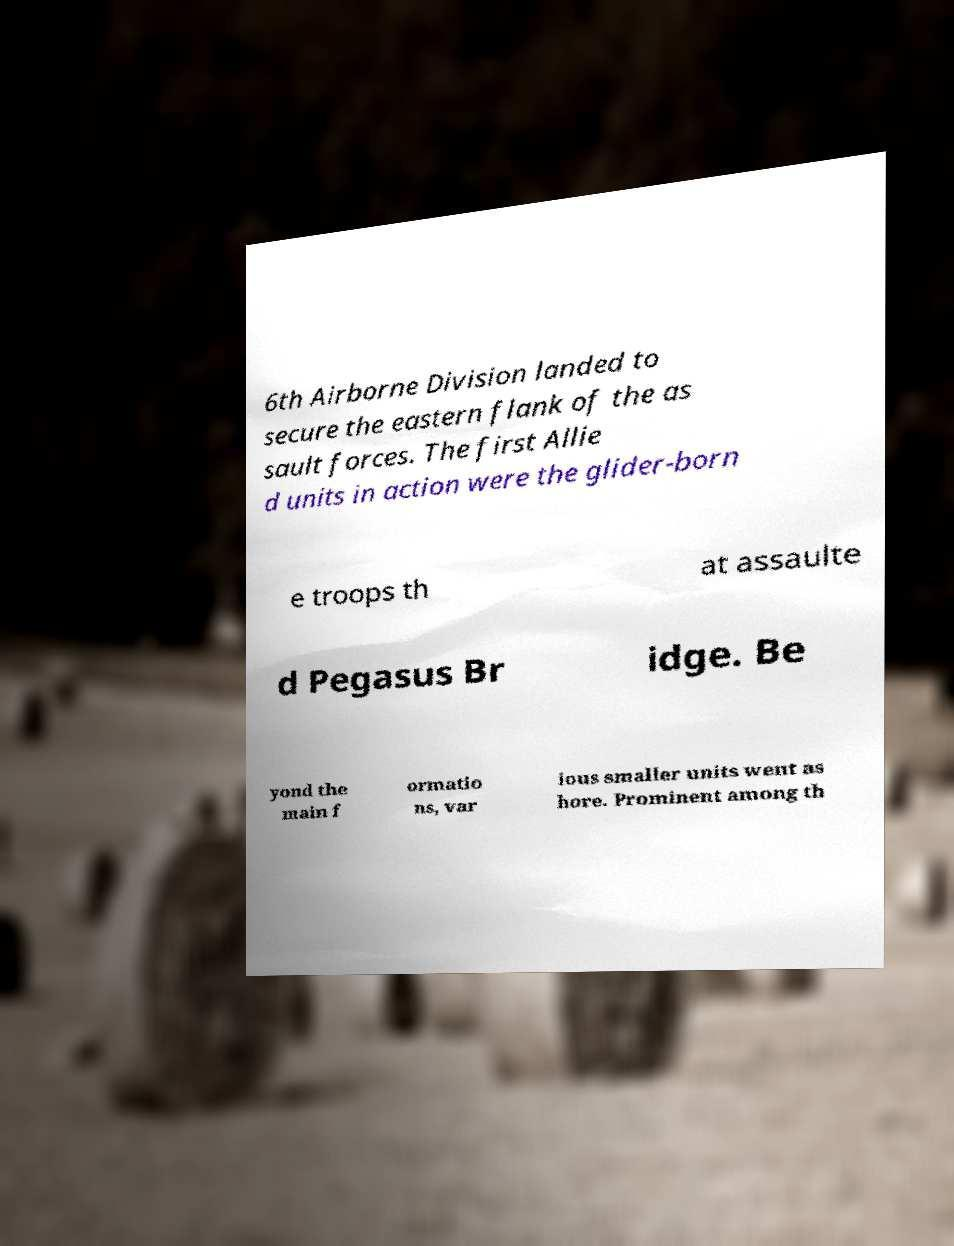Can you accurately transcribe the text from the provided image for me? 6th Airborne Division landed to secure the eastern flank of the as sault forces. The first Allie d units in action were the glider-born e troops th at assaulte d Pegasus Br idge. Be yond the main f ormatio ns, var ious smaller units went as hore. Prominent among th 